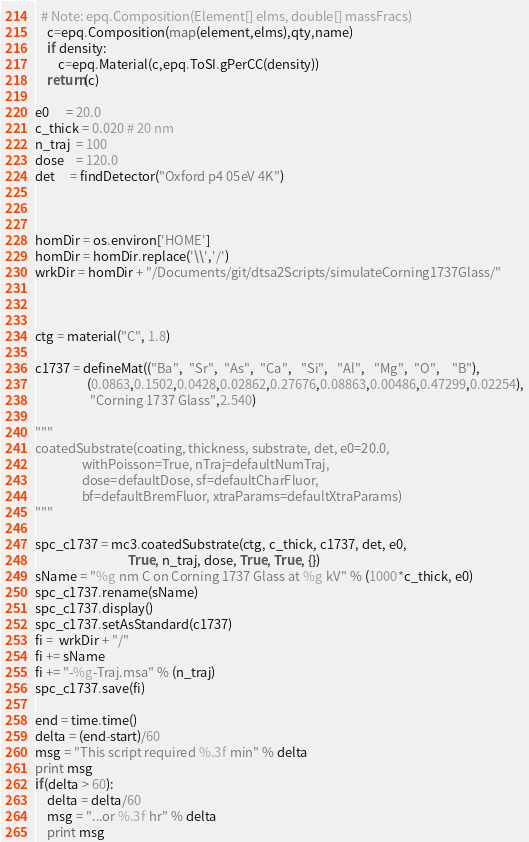<code> <loc_0><loc_0><loc_500><loc_500><_Python_>  # Note: epq.Composition(Element[] elms, double[] massFracs)
	c=epq.Composition(map(element,elms),qty,name)
	if density:
		c=epq.Material(c,epq.ToSI.gPerCC(density))
	return(c)

e0      = 20.0
c_thick = 0.020 # 20 nm
n_traj  = 100
dose    = 120.0
det     = findDetector("Oxford p4 05eV 4K")



homDir = os.environ['HOME']
homDir = homDir.replace('\\','/')
wrkDir = homDir + "/Documents/git/dtsa2Scripts/simulateCorning1737Glass/"



ctg = material("C", 1.8)

c1737 = defineMat(("Ba",  "Sr",  "As",  "Ca",   "Si",   "Al",   "Mg",  "O",    "B"),
	              (0.0863,0.1502,0.0428,0.02862,0.27676,0.08863,0.00486,0.47299,0.02254),
	               "Corning 1737 Glass",2.540)

"""
coatedSubstrate(coating, thickness, substrate, det, e0=20.0,
                withPoisson=True, nTraj=defaultNumTraj,
                dose=defaultDose, sf=defaultCharFluor,
                bf=defaultBremFluor, xtraParams=defaultXtraParams)
"""

spc_c1737 = mc3.coatedSubstrate(ctg, c_thick, c1737, det, e0,
                                True, n_traj, dose, True, True, {})
sName = "%g nm C on Corning 1737 Glass at %g kV" % (1000*c_thick, e0)
spc_c1737.rename(sName)
spc_c1737.display()
spc_c1737.setAsStandard(c1737)
fi =  wrkDir + "/"
fi += sName
fi += "-%g-Traj.msa" % (n_traj)
spc_c1737.save(fi)

end = time.time()
delta = (end-start)/60
msg = "This script required %.3f min" % delta
print msg
if(delta > 60):
    delta = delta/60
    msg = "...or %.3f hr" % delta
    print msg
</code> 